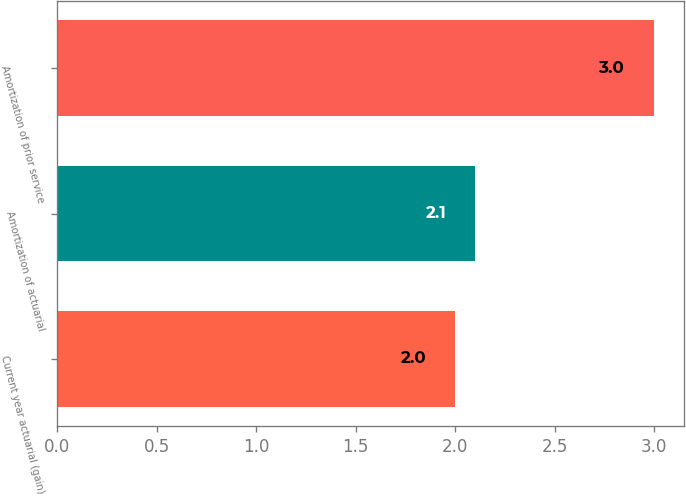Convert chart. <chart><loc_0><loc_0><loc_500><loc_500><bar_chart><fcel>Current year actuarial (gain)<fcel>Amortization of actuarial<fcel>Amortization of prior service<nl><fcel>2<fcel>2.1<fcel>3<nl></chart> 